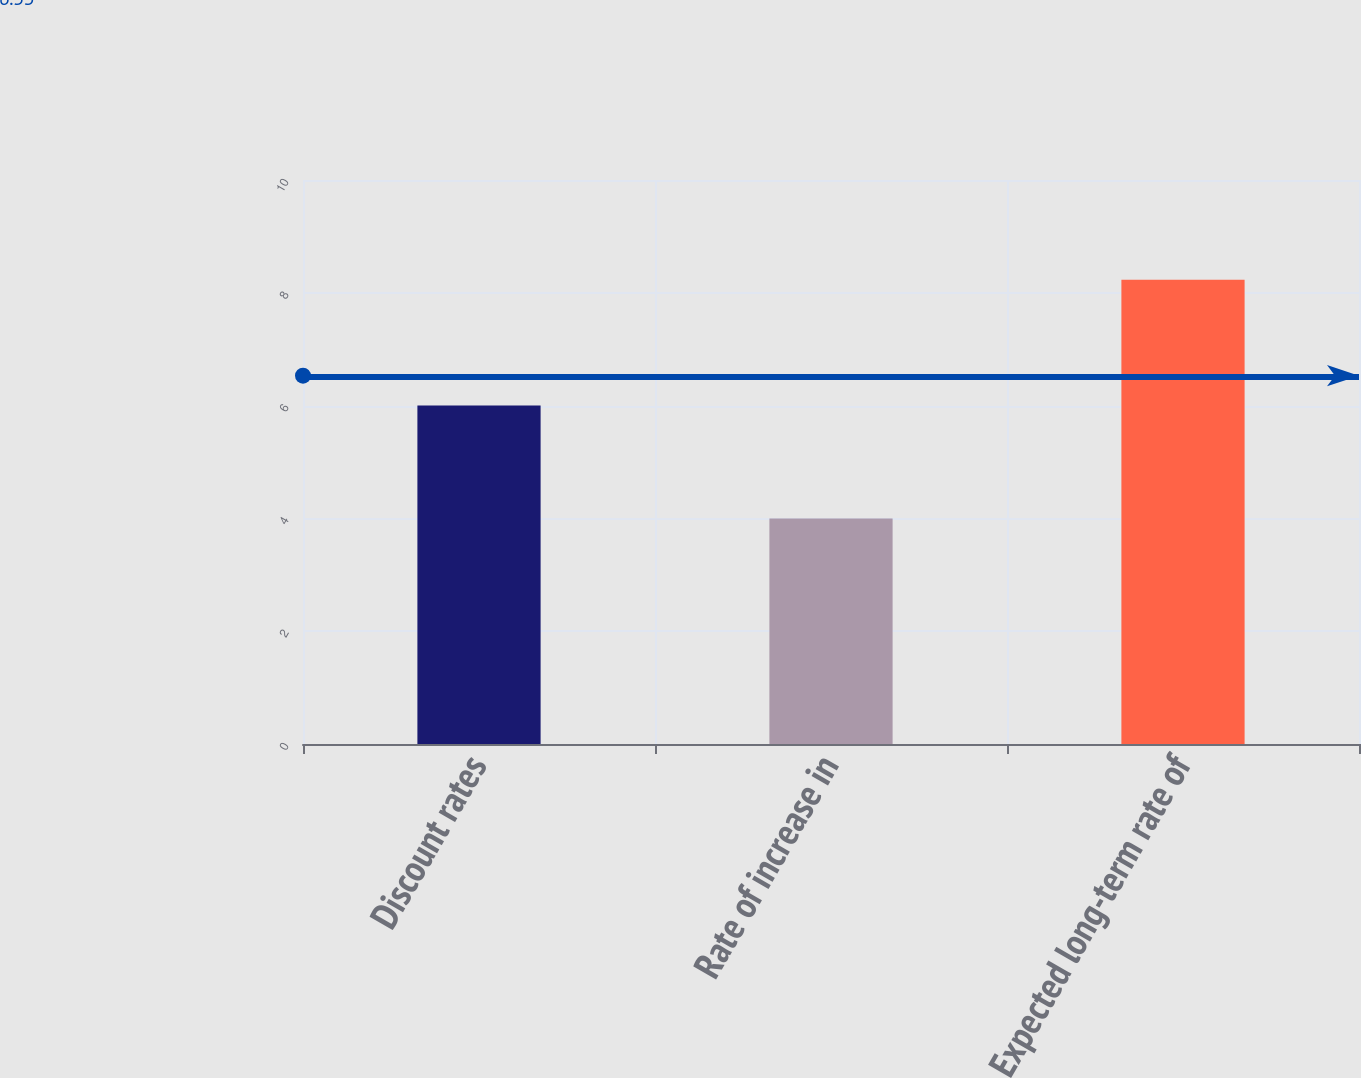<chart> <loc_0><loc_0><loc_500><loc_500><bar_chart><fcel>Discount rates<fcel>Rate of increase in<fcel>Expected long-term rate of<nl><fcel>6<fcel>4<fcel>8.23<nl></chart> 